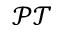<formula> <loc_0><loc_0><loc_500><loc_500>\mathcal { P T }</formula> 